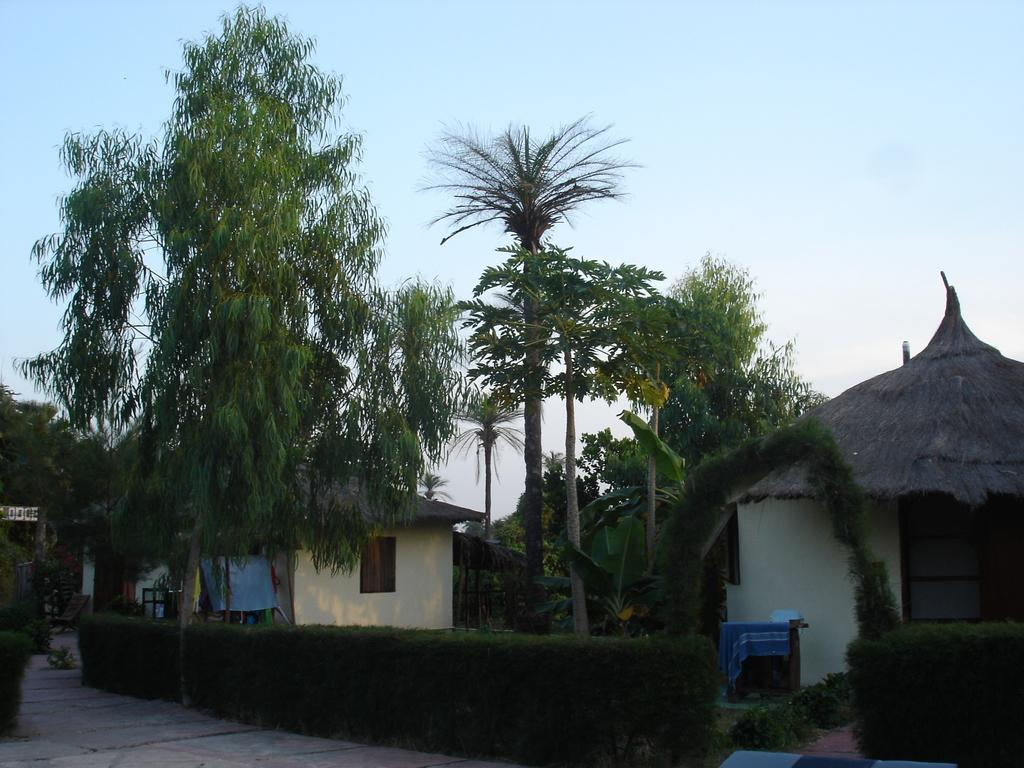What type of structures can be seen in the image? There are houses in the image. What type of vegetation is present in the image? There are trees in the image. What is the condition of the sky in the image? The sky is clear in the image. What type of fowl can be seen embarking on a journey in the image? There is no fowl present in the image, nor is there any indication of a journey. What question is being asked by the houses in the image? There is no indication in the image that the houses are asking any questions. 